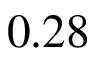<formula> <loc_0><loc_0><loc_500><loc_500>0 . 2 8</formula> 